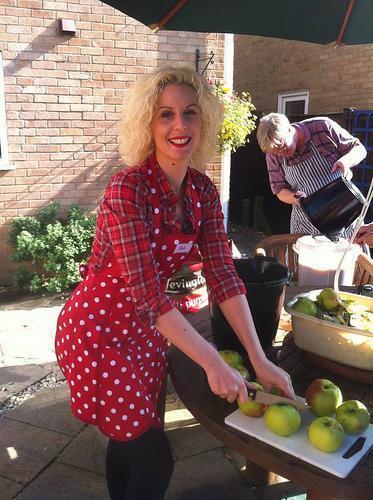How many people in the yard?
Give a very brief answer. 2. How many people wearing a red apron?
Give a very brief answer. 1. 